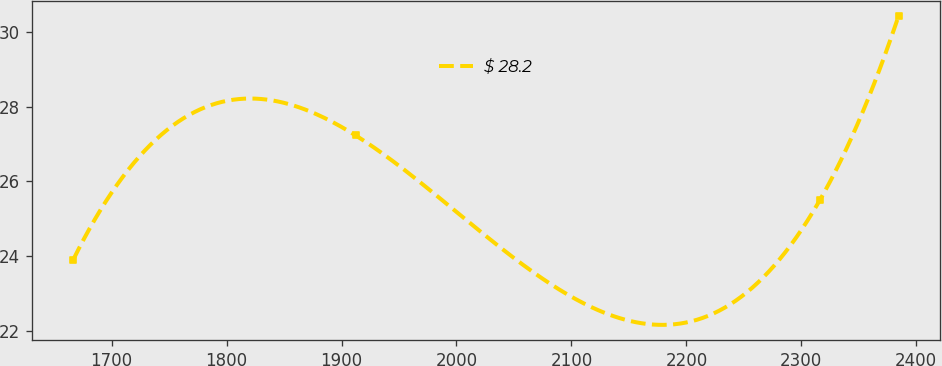Convert chart. <chart><loc_0><loc_0><loc_500><loc_500><line_chart><ecel><fcel>$ 28.2<nl><fcel>1666.54<fcel>23.9<nl><fcel>1912.36<fcel>27.23<nl><fcel>2316.33<fcel>25.51<nl><fcel>2384.6<fcel>30.43<nl></chart> 